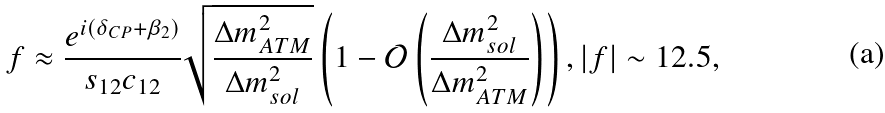<formula> <loc_0><loc_0><loc_500><loc_500>f \approx \frac { e ^ { i ( \delta _ { C P } + \beta _ { 2 } ) } } { s _ { 1 2 } c _ { 1 2 } } \sqrt { \frac { \Delta m _ { A T M } ^ { 2 } } { \Delta m _ { s o l } ^ { 2 } } } \left ( 1 - \mathcal { O } \left ( \frac { \Delta m _ { s o l } ^ { 2 } } { \Delta m _ { A T M } ^ { 2 } } \right ) \right ) , | f | \sim 1 2 . 5 ,</formula> 